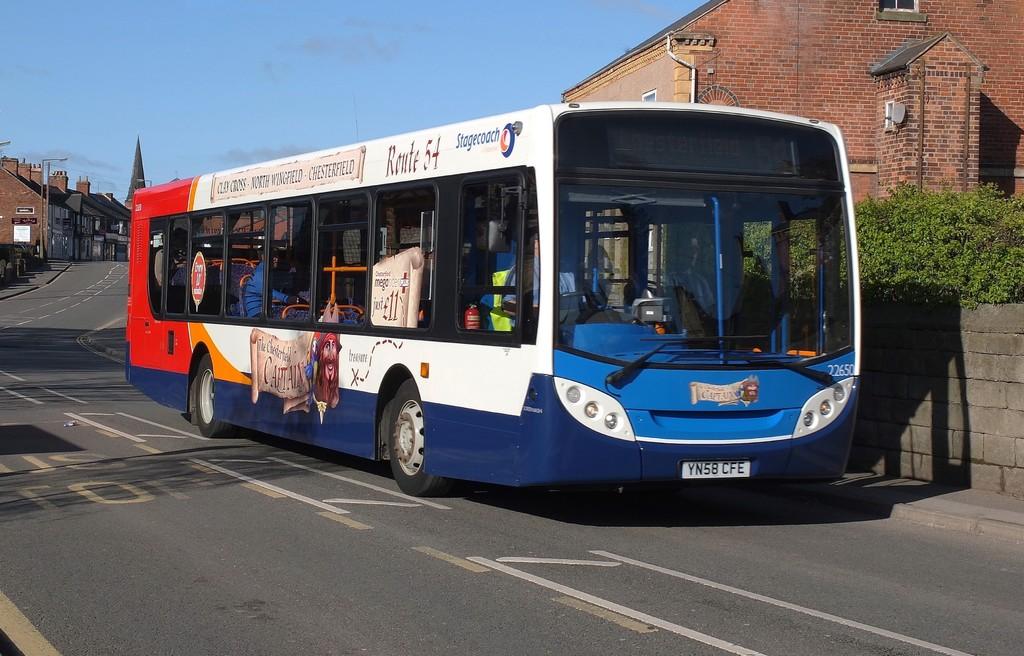What route number bus is this?
Offer a terse response. 54. What is the license plate info>?
Offer a terse response. Yn58 cfe. 